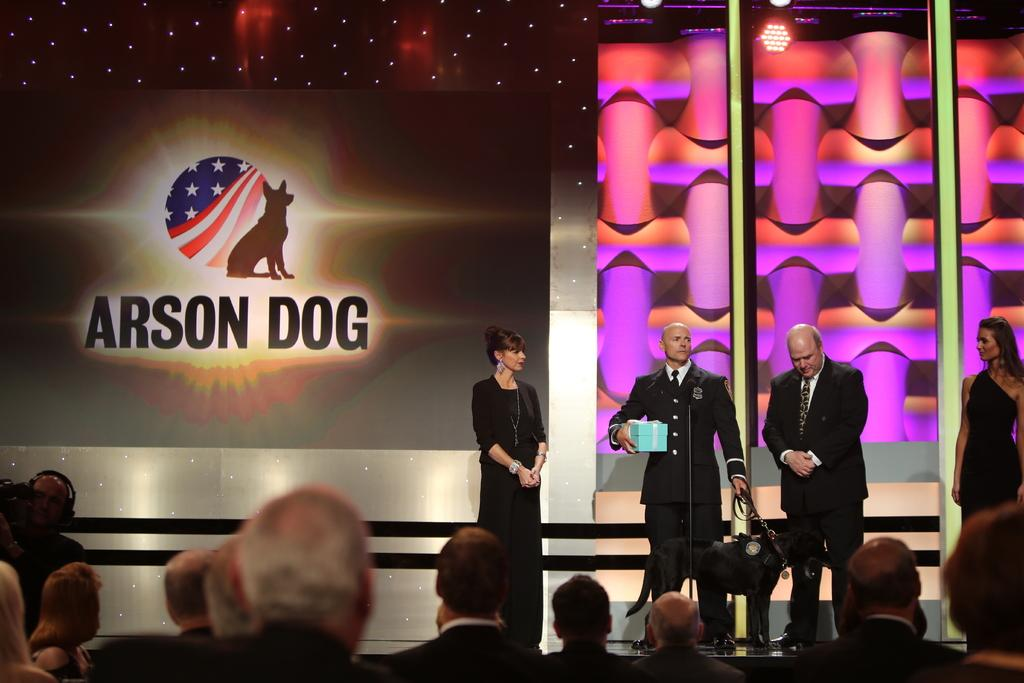<image>
Relay a brief, clear account of the picture shown. a screen that says arson dog on it 